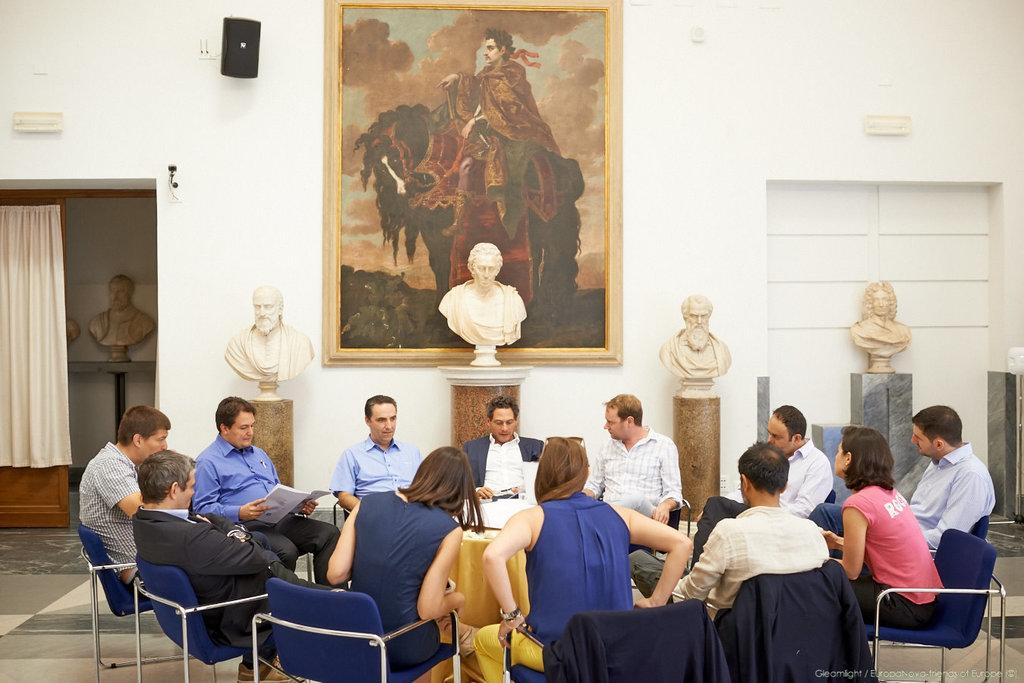What is the arrangement of the table in the image? There are several people sitting at a round table in the image. What can be seen on the table in the background? There are sculptures placed on a table in the background. What is visible in the background besides the table with sculptures? There is a painting visible in the background. Are there any slaves depicted in the painting in the background? There is no mention of slaves or any depiction of them in the image, as the focus is on the people sitting at the round table and the sculptures and painting in the background. 